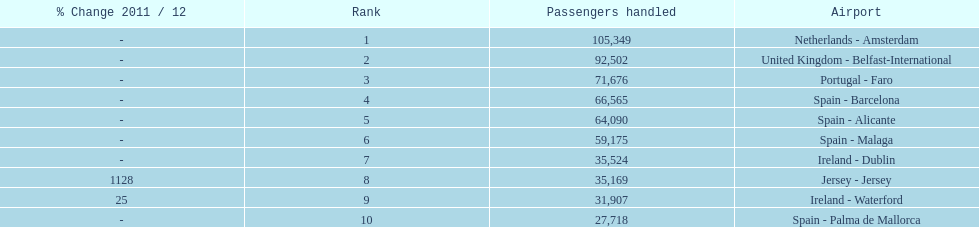Looking at the top 10 busiest routes to and from london southend airport what is the average number of passengers handled? 58,967.5. 